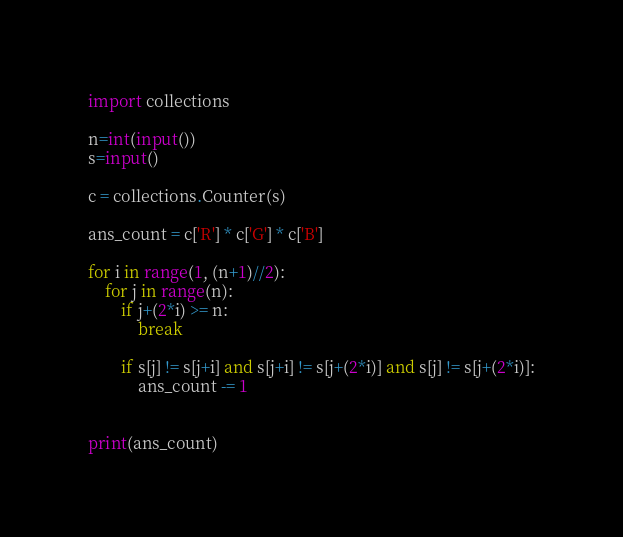<code> <loc_0><loc_0><loc_500><loc_500><_Python_>import collections

n=int(input())	
s=input()

c = collections.Counter(s)

ans_count = c['R'] * c['G'] * c['B']

for i in range(1, (n+1)//2):
    for j in range(n):
        if j+(2*i) >= n:
            break

        if s[j] != s[j+i] and s[j+i] != s[j+(2*i)] and s[j] != s[j+(2*i)]:
            ans_count -= 1


print(ans_count)
</code> 